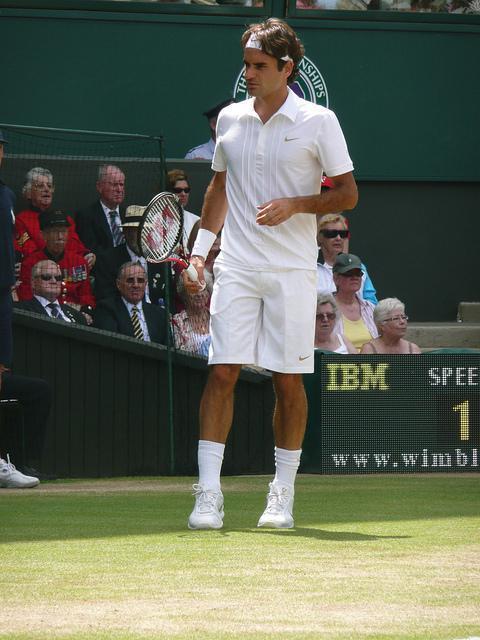How many people can be seen?
Give a very brief answer. 12. 